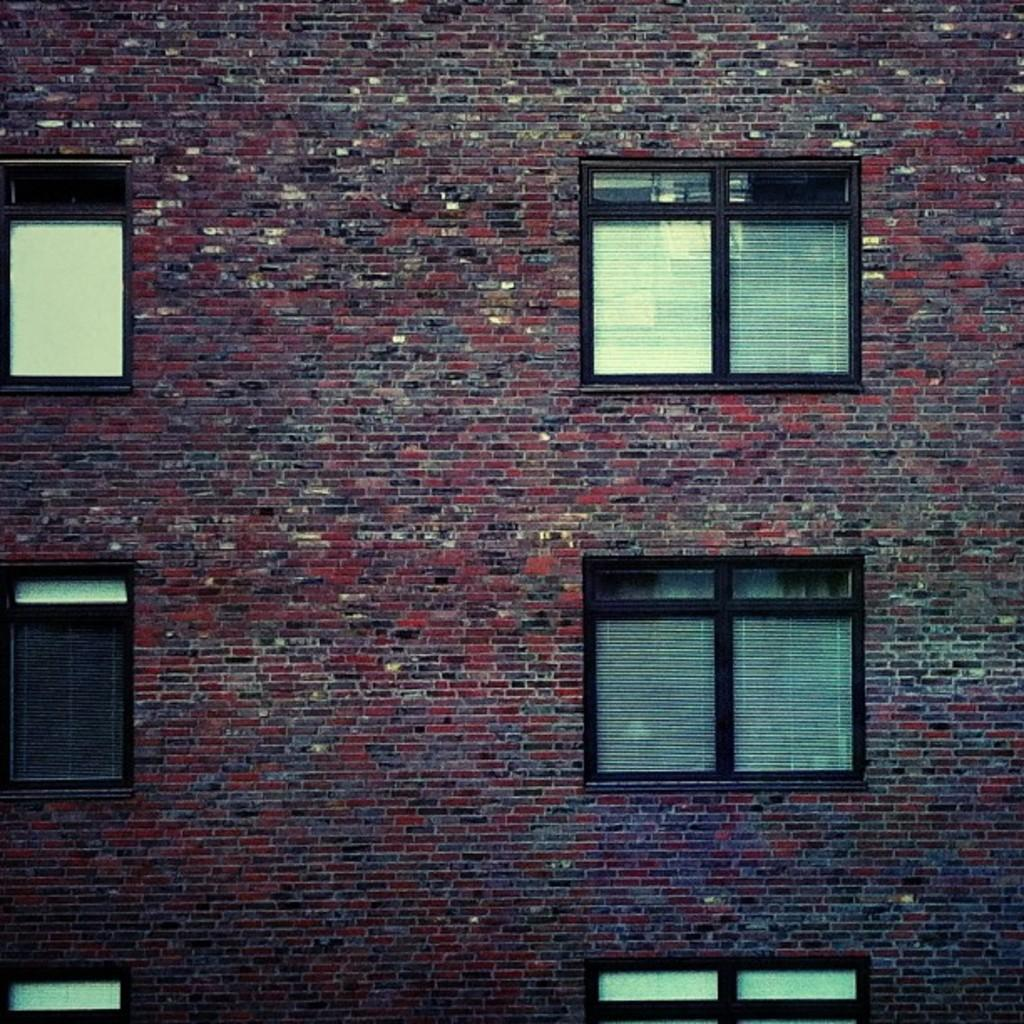What is the main subject of the image? The main subject of the image is a building. Can you describe the building's appearance? The building has a brick wall and windows. Is there a letter addressed to the doctor in the building? There is no information about a letter or a doctor in the image; it only shows a building with a brick wall and windows. 